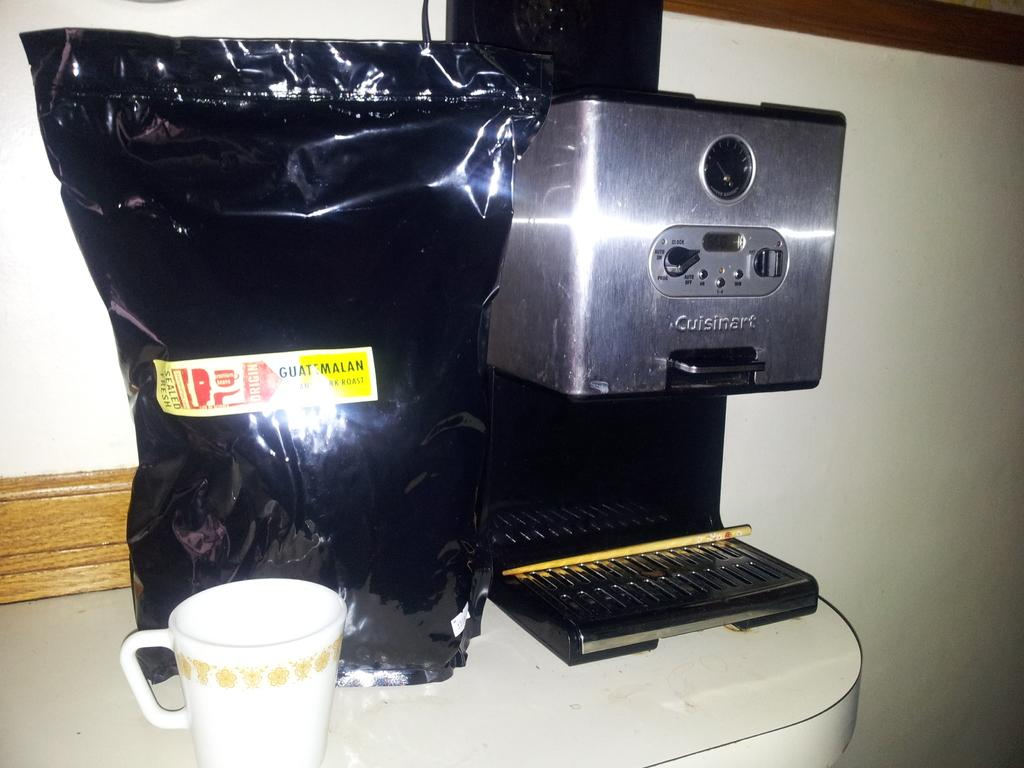<image>
Present a compact description of the photo's key features. A coffee maker and a big bag of coffee that says Guatemalan on it 